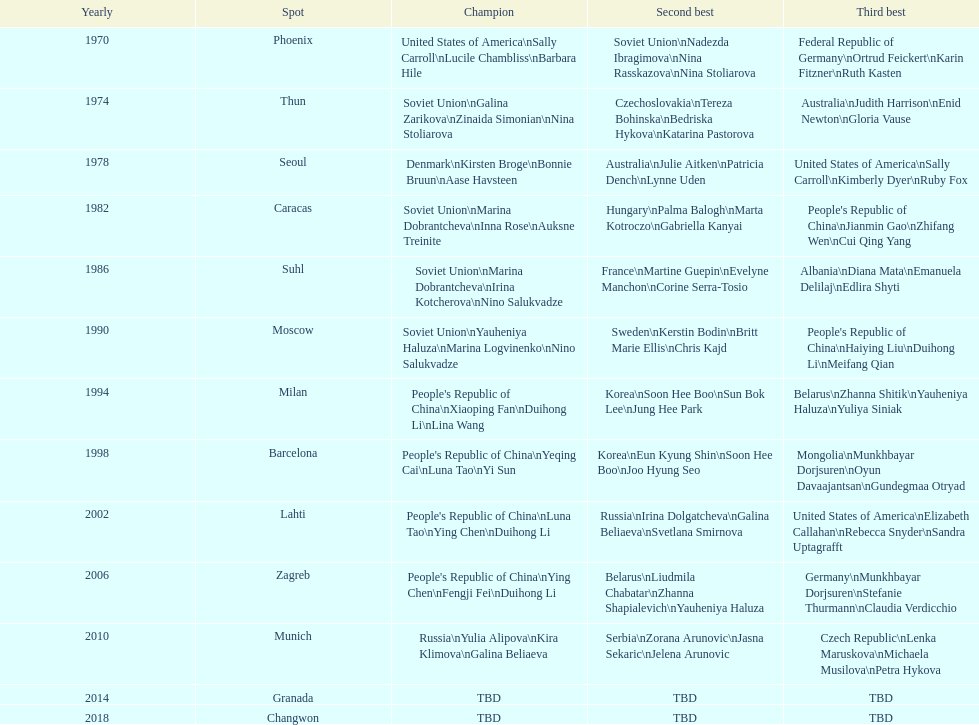How many times has germany won bronze? 2. 